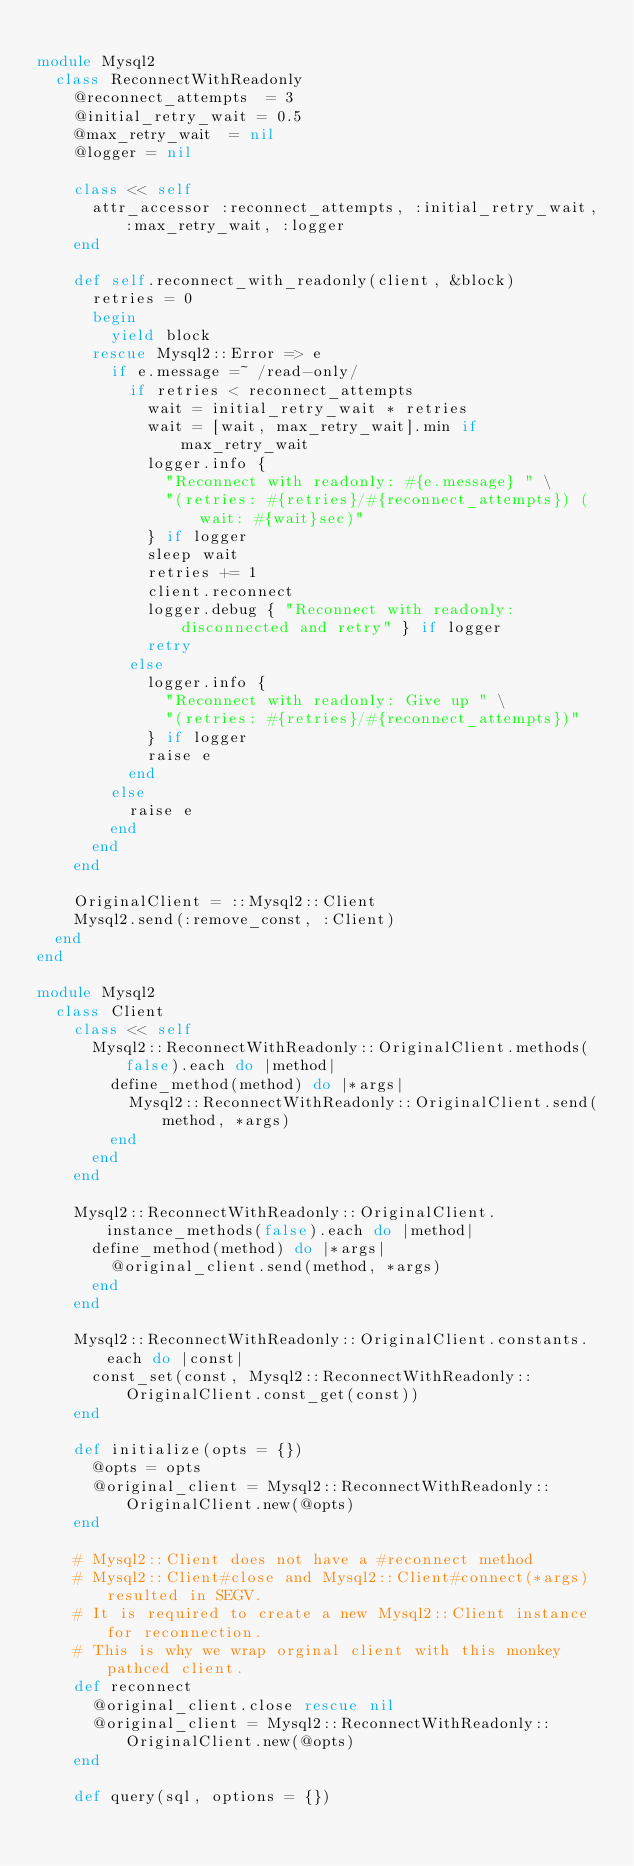Convert code to text. <code><loc_0><loc_0><loc_500><loc_500><_Ruby_>
module Mysql2
  class ReconnectWithReadonly
    @reconnect_attempts  = 3
    @initial_retry_wait = 0.5
    @max_retry_wait  = nil
    @logger = nil

    class << self
      attr_accessor :reconnect_attempts, :initial_retry_wait, :max_retry_wait, :logger
    end

    def self.reconnect_with_readonly(client, &block)
      retries = 0
      begin
        yield block
      rescue Mysql2::Error => e
        if e.message =~ /read-only/
          if retries < reconnect_attempts
            wait = initial_retry_wait * retries
            wait = [wait, max_retry_wait].min if max_retry_wait
            logger.info {
              "Reconnect with readonly: #{e.message} " \
              "(retries: #{retries}/#{reconnect_attempts}) (wait: #{wait}sec)"
            } if logger
            sleep wait
            retries += 1
            client.reconnect
            logger.debug { "Reconnect with readonly: disconnected and retry" } if logger
            retry
          else
            logger.info {
              "Reconnect with readonly: Give up " \
              "(retries: #{retries}/#{reconnect_attempts})"
            } if logger
            raise e
          end
        else
          raise e
        end
      end
    end

    OriginalClient = ::Mysql2::Client
    Mysql2.send(:remove_const, :Client)
  end
end

module Mysql2
  class Client
    class << self
      Mysql2::ReconnectWithReadonly::OriginalClient.methods(false).each do |method|
        define_method(method) do |*args|
          Mysql2::ReconnectWithReadonly::OriginalClient.send(method, *args)
        end
      end
    end

    Mysql2::ReconnectWithReadonly::OriginalClient.instance_methods(false).each do |method|
      define_method(method) do |*args|
        @original_client.send(method, *args)
      end
    end

    Mysql2::ReconnectWithReadonly::OriginalClient.constants.each do |const|
      const_set(const, Mysql2::ReconnectWithReadonly::OriginalClient.const_get(const))
    end

    def initialize(opts = {})
      @opts = opts
      @original_client = Mysql2::ReconnectWithReadonly::OriginalClient.new(@opts)
    end

    # Mysql2::Client does not have a #reconnect method
    # Mysql2::Client#close and Mysql2::Client#connect(*args) resulted in SEGV.
    # It is required to create a new Mysql2::Client instance for reconnection.
    # This is why we wrap orginal client with this monkey pathced client.
    def reconnect
      @original_client.close rescue nil
      @original_client = Mysql2::ReconnectWithReadonly::OriginalClient.new(@opts)
    end

    def query(sql, options = {})</code> 